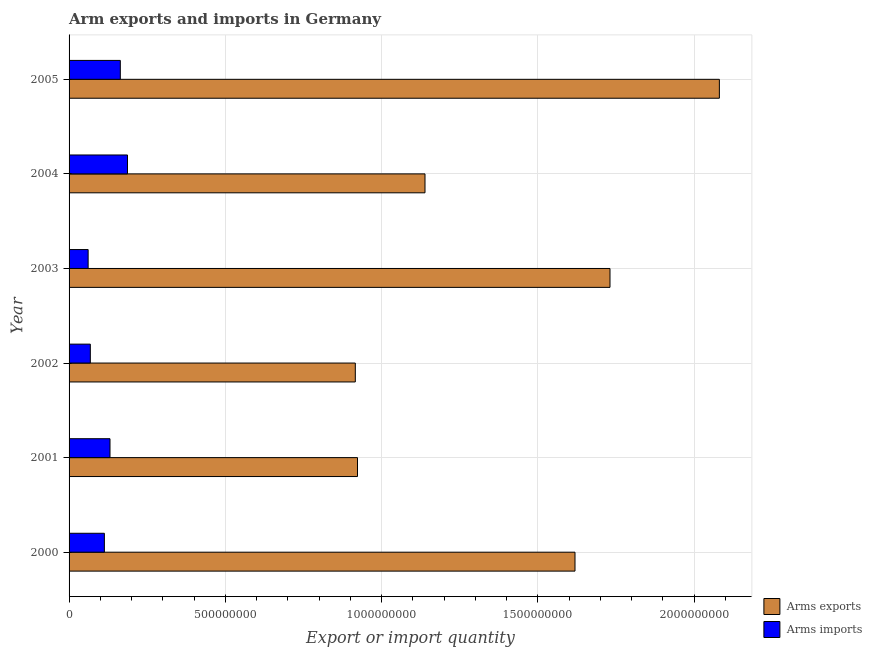How many groups of bars are there?
Your answer should be compact. 6. How many bars are there on the 2nd tick from the top?
Your response must be concise. 2. What is the arms imports in 2003?
Give a very brief answer. 6.10e+07. Across all years, what is the maximum arms imports?
Give a very brief answer. 1.87e+08. Across all years, what is the minimum arms exports?
Keep it short and to the point. 9.16e+08. What is the total arms exports in the graph?
Make the answer very short. 8.41e+09. What is the difference between the arms imports in 2000 and that in 2005?
Provide a succinct answer. -5.10e+07. What is the difference between the arms imports in 2004 and the arms exports in 2003?
Offer a terse response. -1.54e+09. What is the average arms exports per year?
Offer a very short reply. 1.40e+09. In the year 2001, what is the difference between the arms exports and arms imports?
Make the answer very short. 7.92e+08. What is the ratio of the arms exports in 2003 to that in 2004?
Your answer should be compact. 1.52. Is the difference between the arms exports in 2003 and 2004 greater than the difference between the arms imports in 2003 and 2004?
Make the answer very short. Yes. What is the difference between the highest and the second highest arms exports?
Provide a succinct answer. 3.50e+08. What is the difference between the highest and the lowest arms exports?
Give a very brief answer. 1.16e+09. Is the sum of the arms imports in 2001 and 2004 greater than the maximum arms exports across all years?
Give a very brief answer. No. What does the 1st bar from the top in 2000 represents?
Give a very brief answer. Arms imports. What does the 2nd bar from the bottom in 2000 represents?
Provide a short and direct response. Arms imports. Are all the bars in the graph horizontal?
Ensure brevity in your answer.  Yes. How many years are there in the graph?
Your answer should be compact. 6. What is the difference between two consecutive major ticks on the X-axis?
Your response must be concise. 5.00e+08. Are the values on the major ticks of X-axis written in scientific E-notation?
Your answer should be very brief. No. Does the graph contain any zero values?
Give a very brief answer. No. What is the title of the graph?
Your response must be concise. Arm exports and imports in Germany. What is the label or title of the X-axis?
Keep it short and to the point. Export or import quantity. What is the Export or import quantity in Arms exports in 2000?
Your answer should be very brief. 1.62e+09. What is the Export or import quantity in Arms imports in 2000?
Offer a very short reply. 1.13e+08. What is the Export or import quantity of Arms exports in 2001?
Ensure brevity in your answer.  9.23e+08. What is the Export or import quantity in Arms imports in 2001?
Provide a short and direct response. 1.31e+08. What is the Export or import quantity in Arms exports in 2002?
Give a very brief answer. 9.16e+08. What is the Export or import quantity in Arms imports in 2002?
Your answer should be very brief. 6.80e+07. What is the Export or import quantity of Arms exports in 2003?
Give a very brief answer. 1.73e+09. What is the Export or import quantity of Arms imports in 2003?
Provide a succinct answer. 6.10e+07. What is the Export or import quantity in Arms exports in 2004?
Ensure brevity in your answer.  1.14e+09. What is the Export or import quantity in Arms imports in 2004?
Your answer should be very brief. 1.87e+08. What is the Export or import quantity of Arms exports in 2005?
Ensure brevity in your answer.  2.08e+09. What is the Export or import quantity of Arms imports in 2005?
Offer a terse response. 1.64e+08. Across all years, what is the maximum Export or import quantity of Arms exports?
Keep it short and to the point. 2.08e+09. Across all years, what is the maximum Export or import quantity of Arms imports?
Make the answer very short. 1.87e+08. Across all years, what is the minimum Export or import quantity of Arms exports?
Your answer should be compact. 9.16e+08. Across all years, what is the minimum Export or import quantity of Arms imports?
Give a very brief answer. 6.10e+07. What is the total Export or import quantity in Arms exports in the graph?
Offer a terse response. 8.41e+09. What is the total Export or import quantity of Arms imports in the graph?
Your answer should be very brief. 7.24e+08. What is the difference between the Export or import quantity of Arms exports in 2000 and that in 2001?
Offer a terse response. 6.96e+08. What is the difference between the Export or import quantity in Arms imports in 2000 and that in 2001?
Offer a very short reply. -1.80e+07. What is the difference between the Export or import quantity of Arms exports in 2000 and that in 2002?
Provide a short and direct response. 7.03e+08. What is the difference between the Export or import quantity of Arms imports in 2000 and that in 2002?
Your answer should be compact. 4.50e+07. What is the difference between the Export or import quantity in Arms exports in 2000 and that in 2003?
Make the answer very short. -1.12e+08. What is the difference between the Export or import quantity in Arms imports in 2000 and that in 2003?
Keep it short and to the point. 5.20e+07. What is the difference between the Export or import quantity in Arms exports in 2000 and that in 2004?
Keep it short and to the point. 4.80e+08. What is the difference between the Export or import quantity of Arms imports in 2000 and that in 2004?
Provide a short and direct response. -7.40e+07. What is the difference between the Export or import quantity of Arms exports in 2000 and that in 2005?
Make the answer very short. -4.62e+08. What is the difference between the Export or import quantity in Arms imports in 2000 and that in 2005?
Your answer should be very brief. -5.10e+07. What is the difference between the Export or import quantity in Arms imports in 2001 and that in 2002?
Your answer should be compact. 6.30e+07. What is the difference between the Export or import quantity of Arms exports in 2001 and that in 2003?
Your answer should be compact. -8.08e+08. What is the difference between the Export or import quantity of Arms imports in 2001 and that in 2003?
Offer a very short reply. 7.00e+07. What is the difference between the Export or import quantity in Arms exports in 2001 and that in 2004?
Make the answer very short. -2.16e+08. What is the difference between the Export or import quantity of Arms imports in 2001 and that in 2004?
Provide a succinct answer. -5.60e+07. What is the difference between the Export or import quantity in Arms exports in 2001 and that in 2005?
Ensure brevity in your answer.  -1.16e+09. What is the difference between the Export or import quantity of Arms imports in 2001 and that in 2005?
Provide a short and direct response. -3.30e+07. What is the difference between the Export or import quantity in Arms exports in 2002 and that in 2003?
Provide a short and direct response. -8.15e+08. What is the difference between the Export or import quantity of Arms exports in 2002 and that in 2004?
Your response must be concise. -2.23e+08. What is the difference between the Export or import quantity of Arms imports in 2002 and that in 2004?
Offer a very short reply. -1.19e+08. What is the difference between the Export or import quantity in Arms exports in 2002 and that in 2005?
Offer a terse response. -1.16e+09. What is the difference between the Export or import quantity in Arms imports in 2002 and that in 2005?
Offer a very short reply. -9.60e+07. What is the difference between the Export or import quantity of Arms exports in 2003 and that in 2004?
Your answer should be very brief. 5.92e+08. What is the difference between the Export or import quantity in Arms imports in 2003 and that in 2004?
Your answer should be very brief. -1.26e+08. What is the difference between the Export or import quantity in Arms exports in 2003 and that in 2005?
Provide a short and direct response. -3.50e+08. What is the difference between the Export or import quantity of Arms imports in 2003 and that in 2005?
Your answer should be compact. -1.03e+08. What is the difference between the Export or import quantity of Arms exports in 2004 and that in 2005?
Provide a short and direct response. -9.42e+08. What is the difference between the Export or import quantity in Arms imports in 2004 and that in 2005?
Provide a short and direct response. 2.30e+07. What is the difference between the Export or import quantity in Arms exports in 2000 and the Export or import quantity in Arms imports in 2001?
Make the answer very short. 1.49e+09. What is the difference between the Export or import quantity in Arms exports in 2000 and the Export or import quantity in Arms imports in 2002?
Offer a terse response. 1.55e+09. What is the difference between the Export or import quantity of Arms exports in 2000 and the Export or import quantity of Arms imports in 2003?
Offer a very short reply. 1.56e+09. What is the difference between the Export or import quantity in Arms exports in 2000 and the Export or import quantity in Arms imports in 2004?
Your answer should be compact. 1.43e+09. What is the difference between the Export or import quantity in Arms exports in 2000 and the Export or import quantity in Arms imports in 2005?
Offer a very short reply. 1.46e+09. What is the difference between the Export or import quantity of Arms exports in 2001 and the Export or import quantity of Arms imports in 2002?
Your answer should be very brief. 8.55e+08. What is the difference between the Export or import quantity in Arms exports in 2001 and the Export or import quantity in Arms imports in 2003?
Keep it short and to the point. 8.62e+08. What is the difference between the Export or import quantity of Arms exports in 2001 and the Export or import quantity of Arms imports in 2004?
Ensure brevity in your answer.  7.36e+08. What is the difference between the Export or import quantity of Arms exports in 2001 and the Export or import quantity of Arms imports in 2005?
Offer a terse response. 7.59e+08. What is the difference between the Export or import quantity in Arms exports in 2002 and the Export or import quantity in Arms imports in 2003?
Offer a very short reply. 8.55e+08. What is the difference between the Export or import quantity of Arms exports in 2002 and the Export or import quantity of Arms imports in 2004?
Give a very brief answer. 7.29e+08. What is the difference between the Export or import quantity of Arms exports in 2002 and the Export or import quantity of Arms imports in 2005?
Your answer should be very brief. 7.52e+08. What is the difference between the Export or import quantity in Arms exports in 2003 and the Export or import quantity in Arms imports in 2004?
Give a very brief answer. 1.54e+09. What is the difference between the Export or import quantity in Arms exports in 2003 and the Export or import quantity in Arms imports in 2005?
Your response must be concise. 1.57e+09. What is the difference between the Export or import quantity in Arms exports in 2004 and the Export or import quantity in Arms imports in 2005?
Ensure brevity in your answer.  9.75e+08. What is the average Export or import quantity in Arms exports per year?
Give a very brief answer. 1.40e+09. What is the average Export or import quantity of Arms imports per year?
Provide a succinct answer. 1.21e+08. In the year 2000, what is the difference between the Export or import quantity of Arms exports and Export or import quantity of Arms imports?
Offer a terse response. 1.51e+09. In the year 2001, what is the difference between the Export or import quantity of Arms exports and Export or import quantity of Arms imports?
Keep it short and to the point. 7.92e+08. In the year 2002, what is the difference between the Export or import quantity of Arms exports and Export or import quantity of Arms imports?
Your answer should be compact. 8.48e+08. In the year 2003, what is the difference between the Export or import quantity of Arms exports and Export or import quantity of Arms imports?
Offer a terse response. 1.67e+09. In the year 2004, what is the difference between the Export or import quantity in Arms exports and Export or import quantity in Arms imports?
Give a very brief answer. 9.52e+08. In the year 2005, what is the difference between the Export or import quantity in Arms exports and Export or import quantity in Arms imports?
Your answer should be compact. 1.92e+09. What is the ratio of the Export or import quantity in Arms exports in 2000 to that in 2001?
Keep it short and to the point. 1.75. What is the ratio of the Export or import quantity of Arms imports in 2000 to that in 2001?
Provide a succinct answer. 0.86. What is the ratio of the Export or import quantity in Arms exports in 2000 to that in 2002?
Ensure brevity in your answer.  1.77. What is the ratio of the Export or import quantity of Arms imports in 2000 to that in 2002?
Offer a very short reply. 1.66. What is the ratio of the Export or import quantity in Arms exports in 2000 to that in 2003?
Your answer should be compact. 0.94. What is the ratio of the Export or import quantity of Arms imports in 2000 to that in 2003?
Your answer should be very brief. 1.85. What is the ratio of the Export or import quantity in Arms exports in 2000 to that in 2004?
Offer a terse response. 1.42. What is the ratio of the Export or import quantity of Arms imports in 2000 to that in 2004?
Provide a succinct answer. 0.6. What is the ratio of the Export or import quantity in Arms exports in 2000 to that in 2005?
Offer a very short reply. 0.78. What is the ratio of the Export or import quantity in Arms imports in 2000 to that in 2005?
Give a very brief answer. 0.69. What is the ratio of the Export or import quantity in Arms exports in 2001 to that in 2002?
Make the answer very short. 1.01. What is the ratio of the Export or import quantity in Arms imports in 2001 to that in 2002?
Keep it short and to the point. 1.93. What is the ratio of the Export or import quantity in Arms exports in 2001 to that in 2003?
Your answer should be very brief. 0.53. What is the ratio of the Export or import quantity in Arms imports in 2001 to that in 2003?
Your answer should be compact. 2.15. What is the ratio of the Export or import quantity in Arms exports in 2001 to that in 2004?
Ensure brevity in your answer.  0.81. What is the ratio of the Export or import quantity of Arms imports in 2001 to that in 2004?
Your response must be concise. 0.7. What is the ratio of the Export or import quantity in Arms exports in 2001 to that in 2005?
Offer a terse response. 0.44. What is the ratio of the Export or import quantity of Arms imports in 2001 to that in 2005?
Ensure brevity in your answer.  0.8. What is the ratio of the Export or import quantity of Arms exports in 2002 to that in 2003?
Keep it short and to the point. 0.53. What is the ratio of the Export or import quantity in Arms imports in 2002 to that in 2003?
Provide a succinct answer. 1.11. What is the ratio of the Export or import quantity in Arms exports in 2002 to that in 2004?
Provide a short and direct response. 0.8. What is the ratio of the Export or import quantity of Arms imports in 2002 to that in 2004?
Provide a short and direct response. 0.36. What is the ratio of the Export or import quantity of Arms exports in 2002 to that in 2005?
Provide a succinct answer. 0.44. What is the ratio of the Export or import quantity in Arms imports in 2002 to that in 2005?
Ensure brevity in your answer.  0.41. What is the ratio of the Export or import quantity of Arms exports in 2003 to that in 2004?
Offer a terse response. 1.52. What is the ratio of the Export or import quantity of Arms imports in 2003 to that in 2004?
Provide a succinct answer. 0.33. What is the ratio of the Export or import quantity in Arms exports in 2003 to that in 2005?
Offer a very short reply. 0.83. What is the ratio of the Export or import quantity in Arms imports in 2003 to that in 2005?
Provide a succinct answer. 0.37. What is the ratio of the Export or import quantity in Arms exports in 2004 to that in 2005?
Offer a very short reply. 0.55. What is the ratio of the Export or import quantity of Arms imports in 2004 to that in 2005?
Your answer should be compact. 1.14. What is the difference between the highest and the second highest Export or import quantity in Arms exports?
Provide a succinct answer. 3.50e+08. What is the difference between the highest and the second highest Export or import quantity in Arms imports?
Make the answer very short. 2.30e+07. What is the difference between the highest and the lowest Export or import quantity in Arms exports?
Make the answer very short. 1.16e+09. What is the difference between the highest and the lowest Export or import quantity of Arms imports?
Offer a terse response. 1.26e+08. 